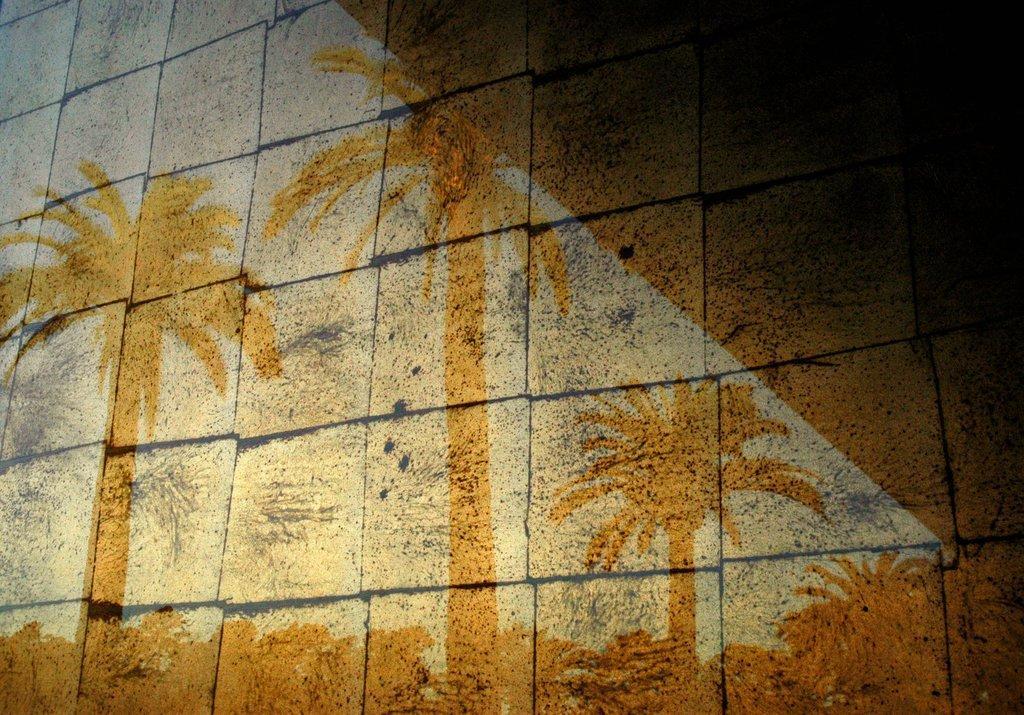Can you describe this image briefly? Shadow of palm trees is casting on a wall with large bricks. There are black lines in between the bricks. 